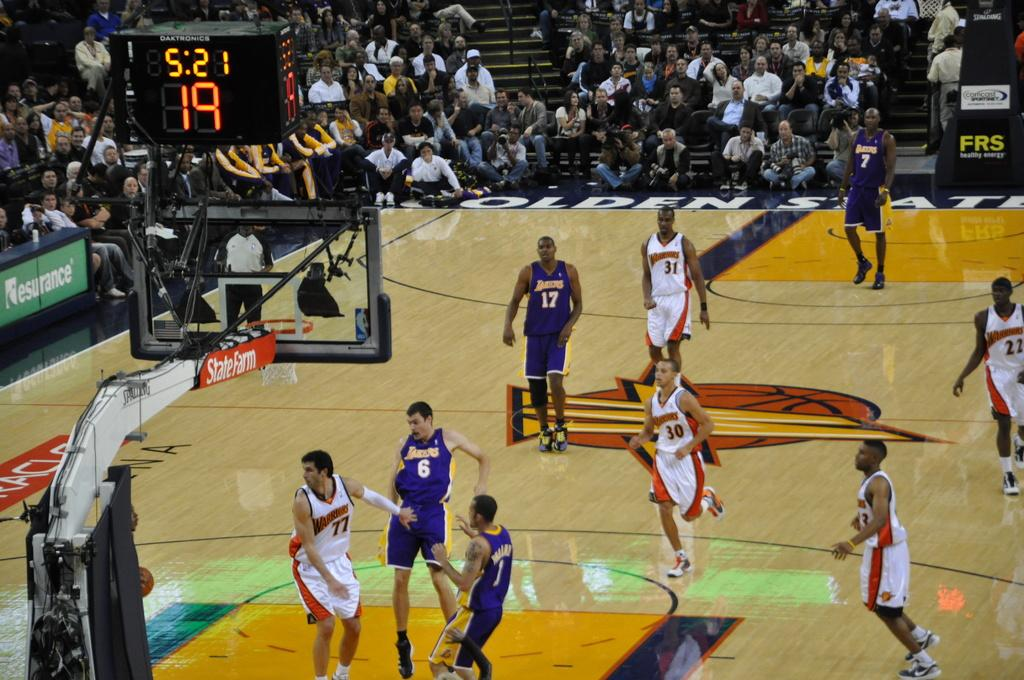<image>
Create a compact narrative representing the image presented. NBA game between the lakers and the warriors with 5:21 left on the clock. 